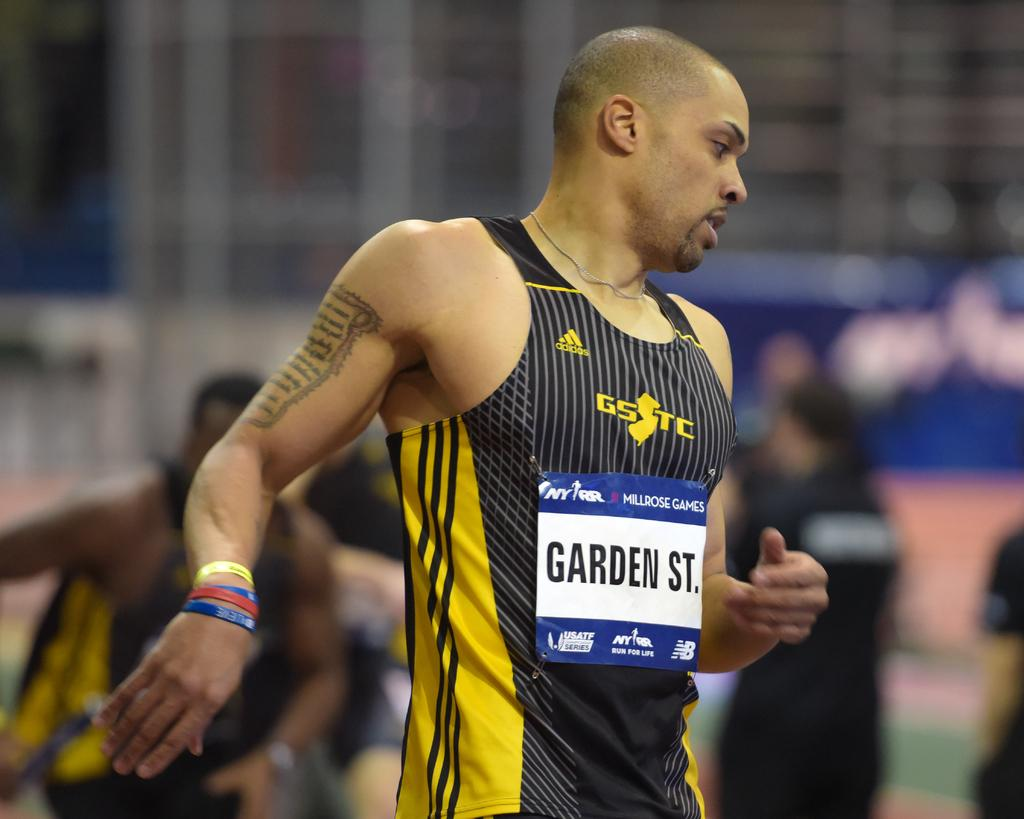<image>
Render a clear and concise summary of the photo. An athlete with "Garden St." on his tank top. 